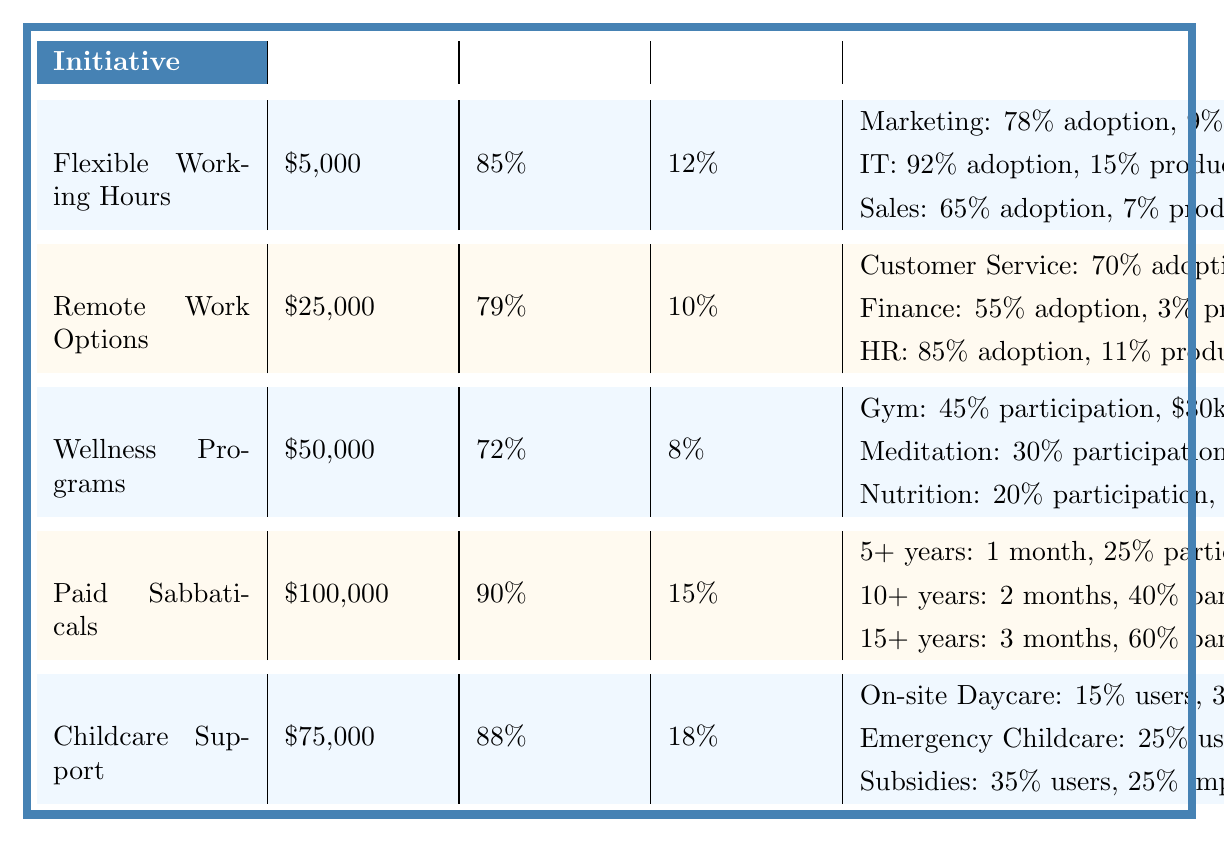What is the implementation cost of the Paid Sabbaticals initiative? The table explicitly lists the implementation cost for each initiative. For Paid Sabbaticals, the cost is stated directly as $100,000.
Answer: $100,000 Which initiative has the highest employee satisfaction rate? By reviewing the employee satisfaction rates for each initiative in the table, Paid Sabbaticals has the highest rate at 90%.
Answer: Paid Sabbaticals What is the total retention rate improvement for Flexible Working Hours and Childcare Support? The retention rate improvements for these initiatives are 12% for Flexible Working Hours and 18% for Childcare Support. Adding these values together: 12% + 18% = 30%.
Answer: 30% Is the adoption rate for Remote Work Options in the Finance department higher than in Customer Service? The adoption rates listed state that Finance has an adoption rate of 55% and Customer Service has 70%. Since 55% is less than 70%, the statement is false.
Answer: No What is the average employee satisfaction rate across all initiatives? First, gather the employee satisfaction rates: 85%, 79%, 72%, 90%, 88%. Sum these up (85 + 79 + 72 + 90 + 88 = 414) and divide by the number of initiatives (5). The average becomes 414 / 5 = 82.8%.
Answer: 82.8% How much does the implementation of Childcare Support improve work-life balance for On-site Daycare users? The table states that On-site Daycare is used by 15% of employees and contributes to a 30% improvement in work-life balance. Therefore, it improves work-life balance for those users by 30%.
Answer: 30% Which initiative has the lowest retention rate improvement and what is that rate? By examining the retention rate improvements, Wellness Programs has the lowest rate at 8%.
Answer: 8% Which department has the highest productivity increase from Flexible Working Hours? From the table, IT has the highest productivity increase from Flexible Working Hours at 15%.
Answer: IT How many employees participate in the Nutrition Counseling program based on the rates provided? The table shows the participation rate in Nutrition Counseling is 20%. If considering total employees as 100% for calculation, it indicates that 20 out of every 100 employees participate.
Answer: 20% of employees What is the percentage difference in retention rate improvement between Paid Sabbaticals and Wellness Programs? The retention rate improvement for Paid Sabbaticals is 15% and for Wellness Programs is 8%. The difference is 15% - 8% = 7%.
Answer: 7% 